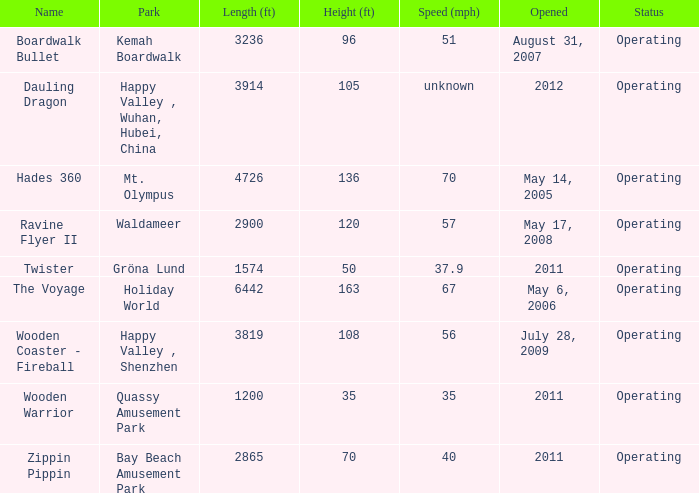In how many parks does zippin pippin exist? 1.0. Could you parse the entire table as a dict? {'header': ['Name', 'Park', 'Length (ft)', 'Height (ft)', 'Speed (mph)', 'Opened', 'Status'], 'rows': [['Boardwalk Bullet', 'Kemah Boardwalk', '3236', '96', '51', 'August 31, 2007', 'Operating'], ['Dauling Dragon', 'Happy Valley , Wuhan, Hubei, China', '3914', '105', 'unknown', '2012', 'Operating'], ['Hades 360', 'Mt. Olympus', '4726', '136', '70', 'May 14, 2005', 'Operating'], ['Ravine Flyer II', 'Waldameer', '2900', '120', '57', 'May 17, 2008', 'Operating'], ['Twister', 'Gröna Lund', '1574', '50', '37.9', '2011', 'Operating'], ['The Voyage', 'Holiday World', '6442', '163', '67', 'May 6, 2006', 'Operating'], ['Wooden Coaster - Fireball', 'Happy Valley , Shenzhen', '3819', '108', '56', 'July 28, 2009', 'Operating'], ['Wooden Warrior', 'Quassy Amusement Park', '1200', '35', '35', '2011', 'Operating'], ['Zippin Pippin', 'Bay Beach Amusement Park', '2865', '70', '40', '2011', 'Operating']]} 